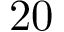<formula> <loc_0><loc_0><loc_500><loc_500>2 0</formula> 